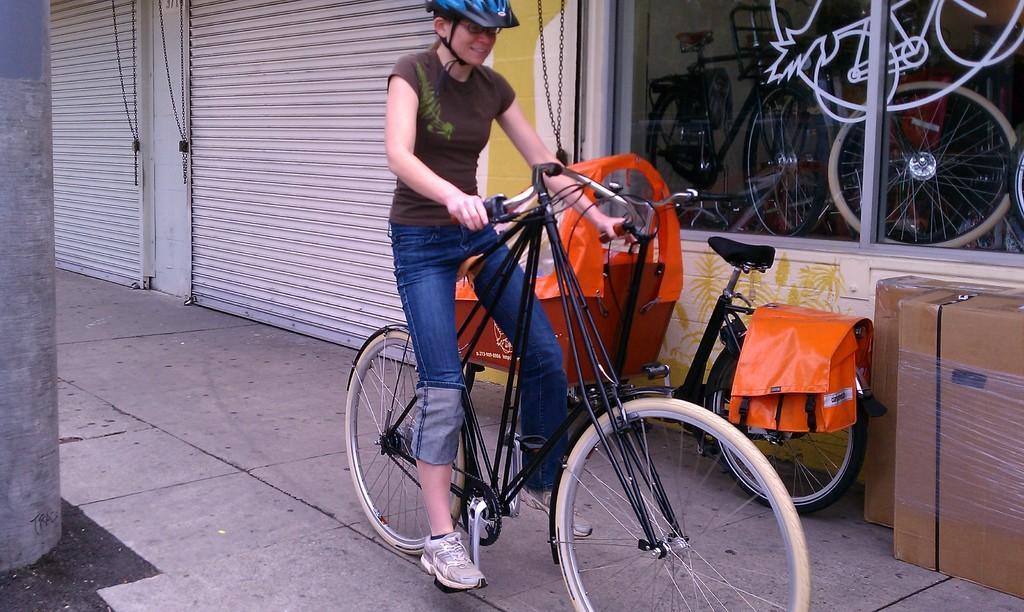Can you describe this image briefly? In this image I can see a person wearing a helmet and sitting on bicycle , beside the person there is another bi-cycle, two boxes and window , through window I can see bicycles visible on right side. In the middle there are two white color shatters visible and a beam visible on the left side. 